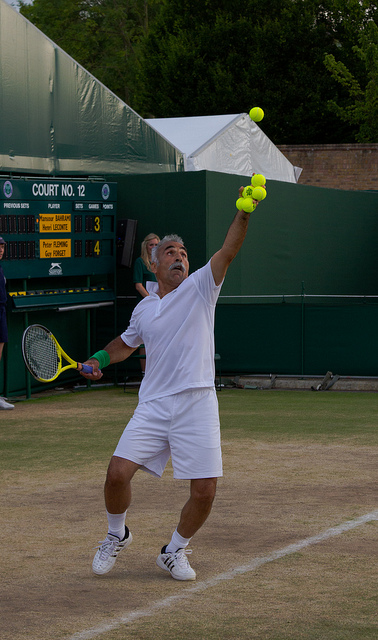<image>How many sets has this man played? I don't know how many sets this man has played. It can be seen 2, 3, or 7 sets. How many sets has this man played? I don't know how many sets this man has played. It can be either 3 or 7. 